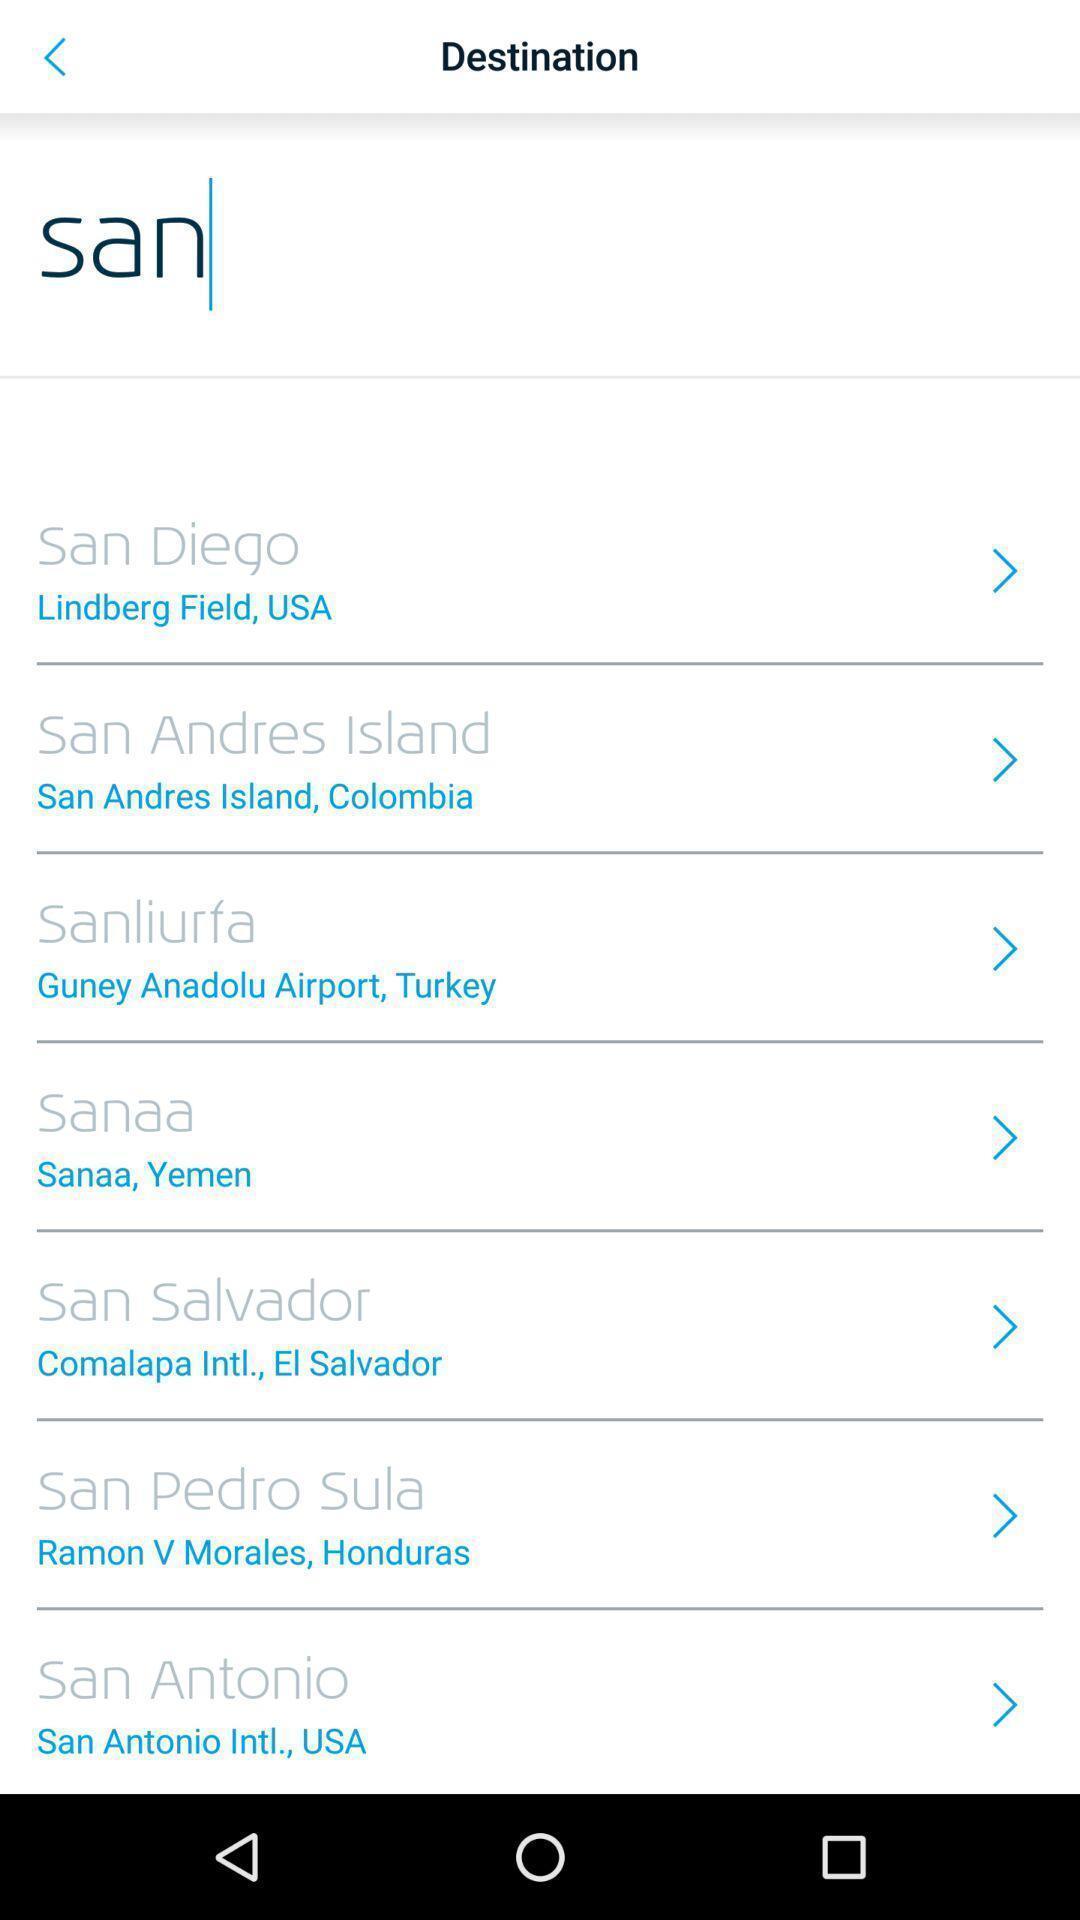Provide a textual representation of this image. Screen displaying list of places to select destination. 